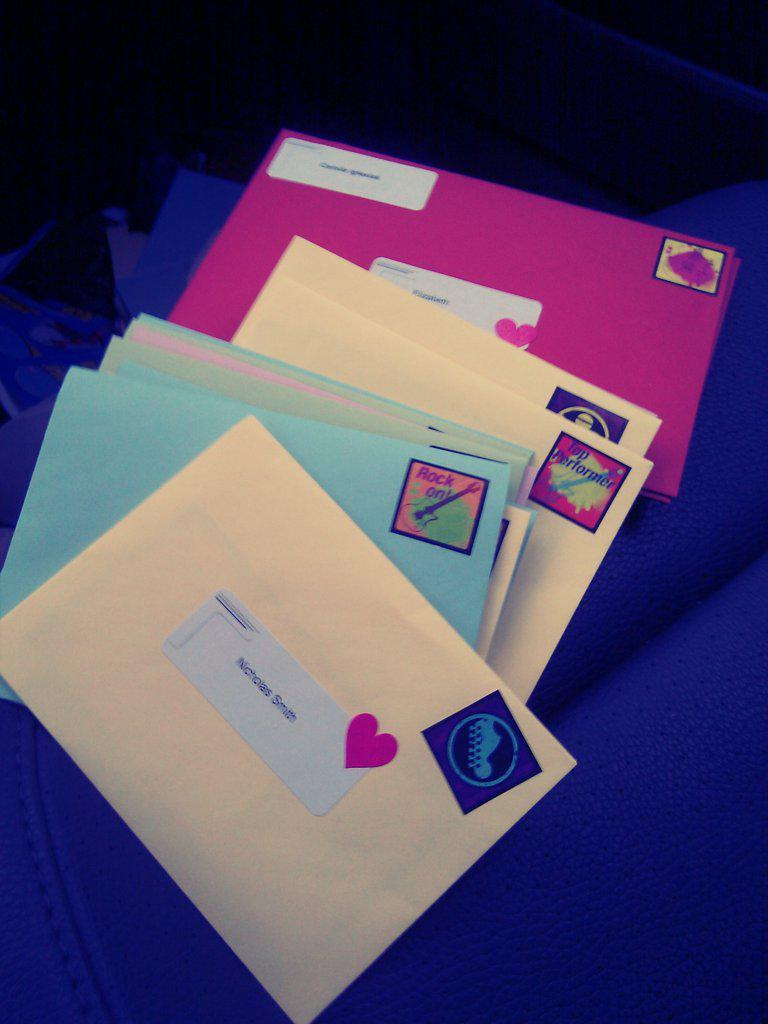<image>
Give a short and clear explanation of the subsequent image. A letter that has been addressed to Nicholas Smith 